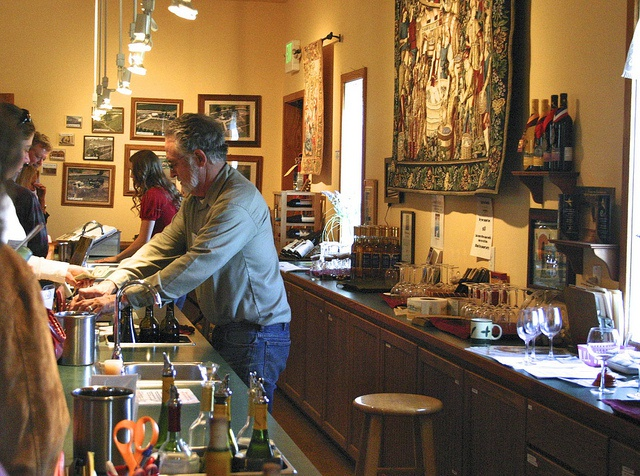Describe the objects in this image and their specific colors. I can see people in olive, black, gray, lightblue, and maroon tones, people in olive, maroon, gray, and black tones, people in olive, black, white, maroon, and gray tones, cup in olive, black, maroon, and gray tones, and people in olive, maroon, black, brown, and gray tones in this image. 